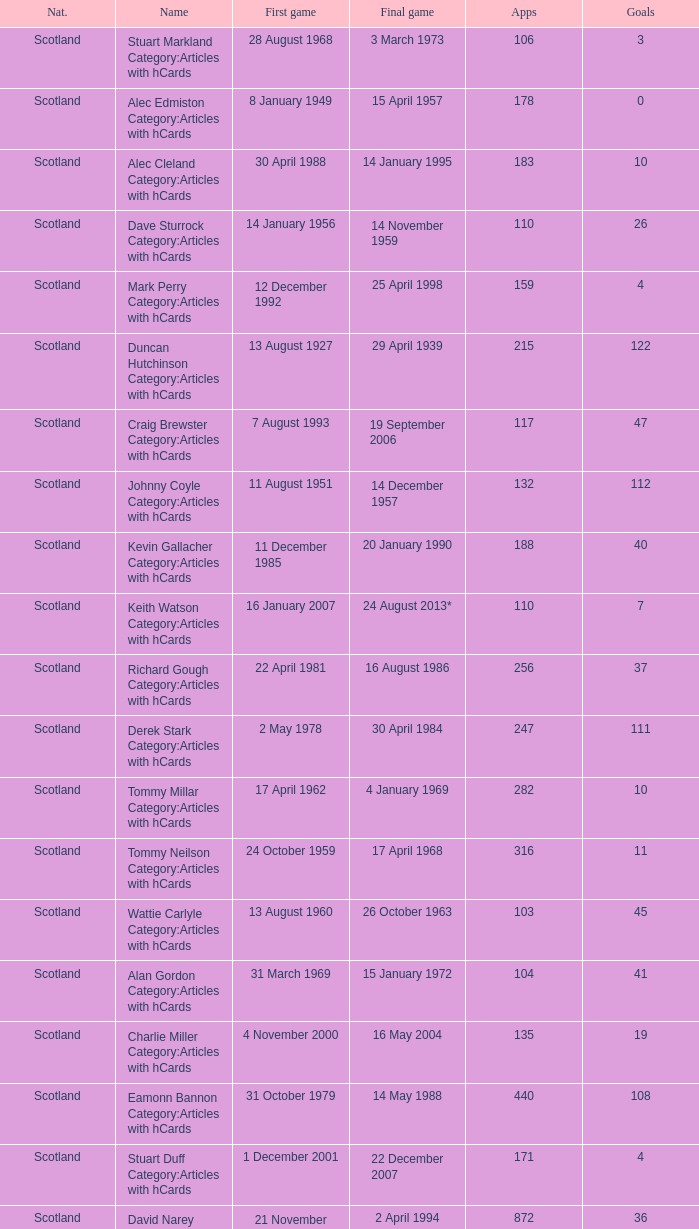What name has 118 as the apps? Ron Yeats Category:Articles with hCards. 